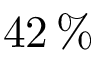<formula> <loc_0><loc_0><loc_500><loc_500>4 2 \, \%</formula> 